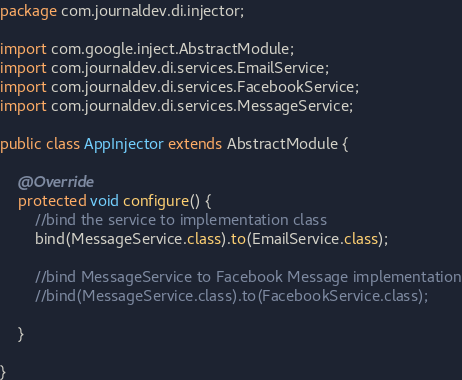<code> <loc_0><loc_0><loc_500><loc_500><_Java_>package com.journaldev.di.injector;

import com.google.inject.AbstractModule;
import com.journaldev.di.services.EmailService;
import com.journaldev.di.services.FacebookService;
import com.journaldev.di.services.MessageService;

public class AppInjector extends AbstractModule {

	@Override
	protected void configure() {
		//bind the service to implementation class
		bind(MessageService.class).to(EmailService.class);
		
		//bind MessageService to Facebook Message implementation
		//bind(MessageService.class).to(FacebookService.class);
		
	}

}
</code> 